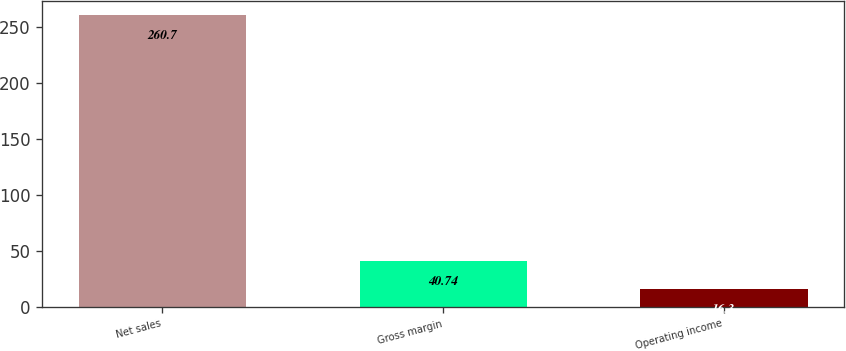Convert chart to OTSL. <chart><loc_0><loc_0><loc_500><loc_500><bar_chart><fcel>Net sales<fcel>Gross margin<fcel>Operating income<nl><fcel>260.7<fcel>40.74<fcel>16.3<nl></chart> 